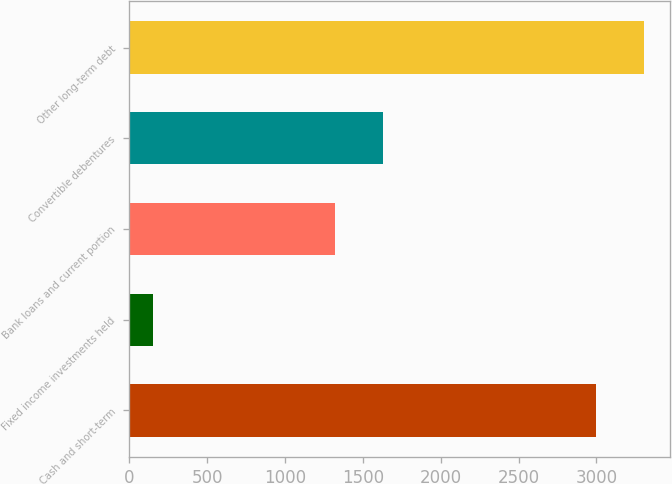<chart> <loc_0><loc_0><loc_500><loc_500><bar_chart><fcel>Cash and short-term<fcel>Fixed income investments held<fcel>Bank loans and current portion<fcel>Convertible debentures<fcel>Other long-term debt<nl><fcel>2999<fcel>153<fcel>1322<fcel>1630.6<fcel>3307.6<nl></chart> 